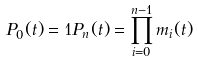Convert formula to latex. <formula><loc_0><loc_0><loc_500><loc_500>P _ { 0 } ( t ) = 1 P _ { n } ( t ) = \prod _ { i = 0 } ^ { n - 1 } m _ { i } ( t ) \quad</formula> 